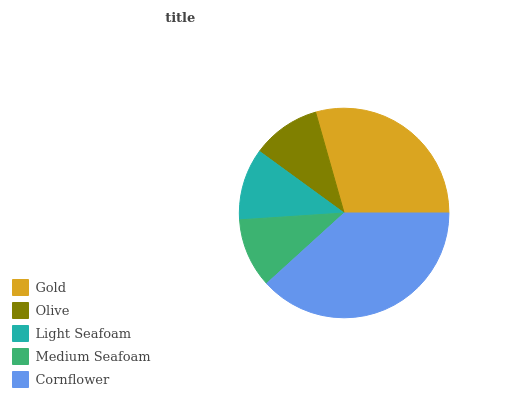Is Olive the minimum?
Answer yes or no. Yes. Is Cornflower the maximum?
Answer yes or no. Yes. Is Light Seafoam the minimum?
Answer yes or no. No. Is Light Seafoam the maximum?
Answer yes or no. No. Is Light Seafoam greater than Olive?
Answer yes or no. Yes. Is Olive less than Light Seafoam?
Answer yes or no. Yes. Is Olive greater than Light Seafoam?
Answer yes or no. No. Is Light Seafoam less than Olive?
Answer yes or no. No. Is Light Seafoam the high median?
Answer yes or no. Yes. Is Light Seafoam the low median?
Answer yes or no. Yes. Is Cornflower the high median?
Answer yes or no. No. Is Cornflower the low median?
Answer yes or no. No. 